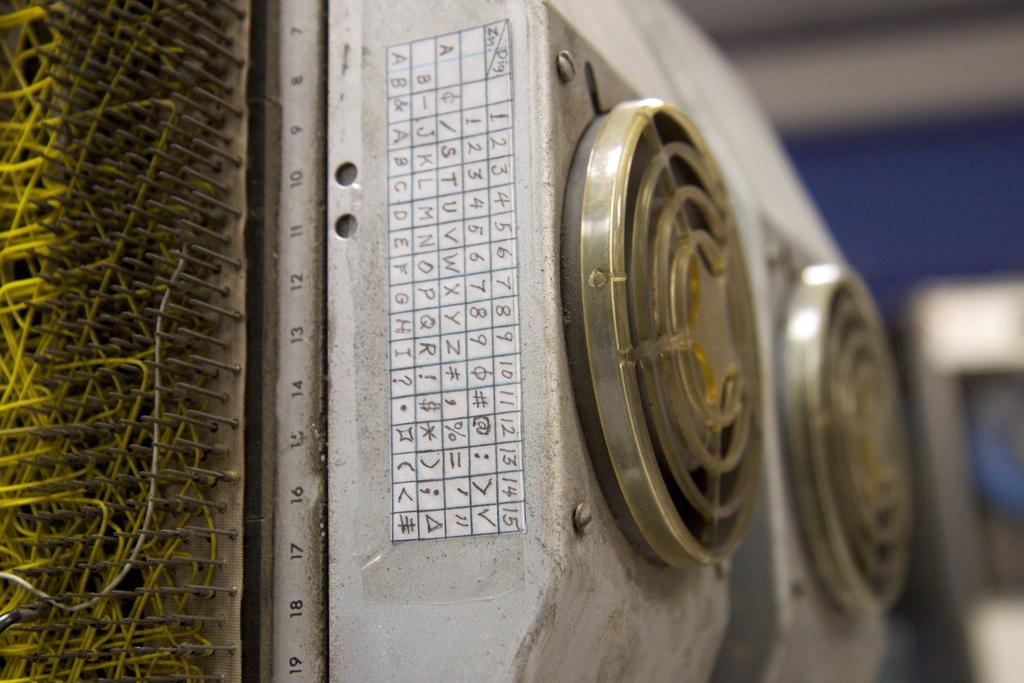What is the main subject of the image? There is a machine in the image. Can you describe the color of the machine? The machine is in ash color. What can be observed about the background of the image? The background of the image is blurred. How many rings are stacked on the machine in the image? There are no rings present on the machine in the image. What type of oatmeal is being prepared in the machine? The image does not show any oatmeal or preparation process; it only features a machine. Can you see a beetle crawling on the machine in the image? There is no beetle visible on the machine in the image. 